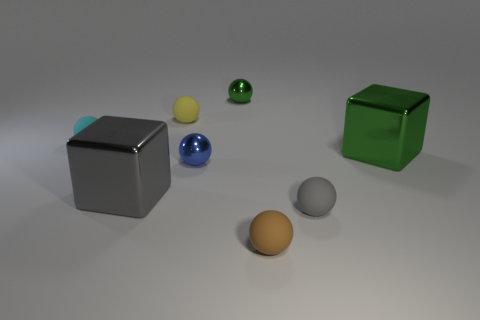Subtract all brown spheres. How many spheres are left? 5 Subtract all green balls. How many balls are left? 5 Subtract all purple balls. Subtract all gray blocks. How many balls are left? 6 Add 1 metallic spheres. How many objects exist? 9 Subtract all spheres. How many objects are left? 2 Subtract 1 green balls. How many objects are left? 7 Subtract all big purple rubber objects. Subtract all small gray matte objects. How many objects are left? 7 Add 7 cyan things. How many cyan things are left? 8 Add 3 small green metallic objects. How many small green metallic objects exist? 4 